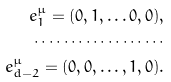Convert formula to latex. <formula><loc_0><loc_0><loc_500><loc_500>e ^ { \mu } _ { 1 } = ( 0 , 1 , \dots 0 , 0 ) , \\ \cdots \cdots \cdots \cdots \cdots \cdots \\ e ^ { \mu } _ { d - 2 } = ( 0 , 0 , \dots , 1 , 0 ) .</formula> 